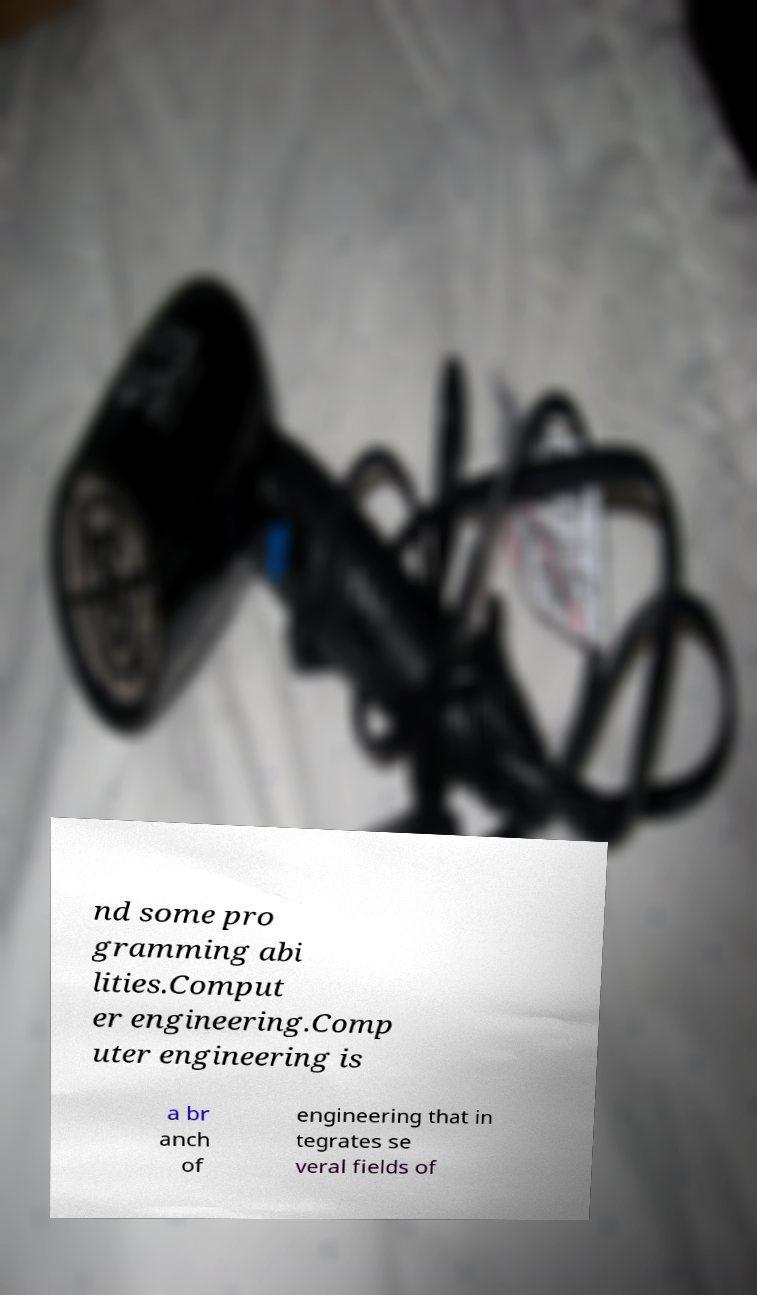What messages or text are displayed in this image? I need them in a readable, typed format. nd some pro gramming abi lities.Comput er engineering.Comp uter engineering is a br anch of engineering that in tegrates se veral fields of 